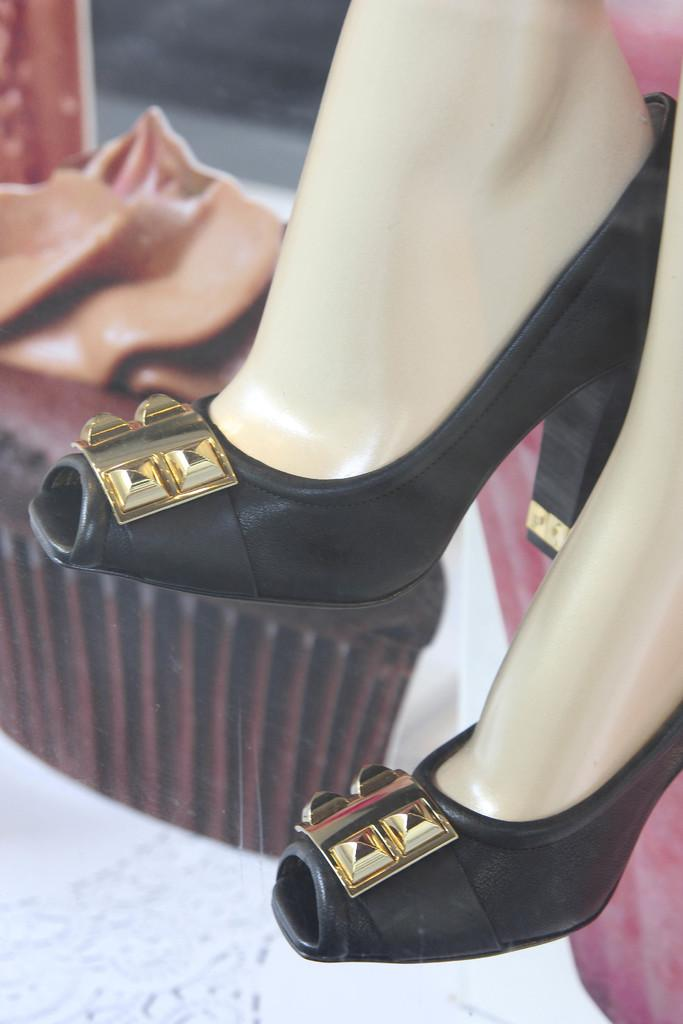What is the main subject of the image? The main subject of the image is a leg of a mannequin. What type of footwear is on the leg of the mannequin? There is a pair of black heels on the leg of the mannequin. What color is the love that the crow is feeling in the image? There is no love or crow present in the image; it only features a leg of a mannequin and a pair of black heels. 